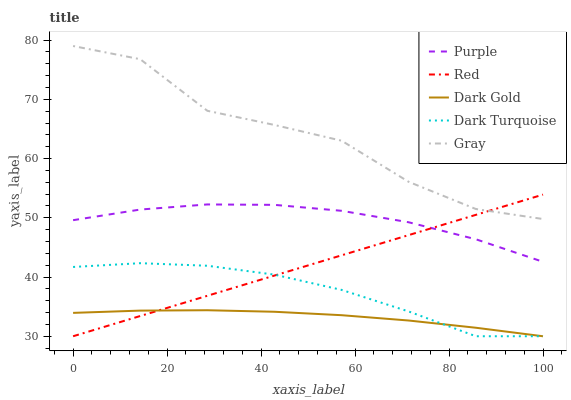Does Dark Turquoise have the minimum area under the curve?
Answer yes or no. No. Does Dark Turquoise have the maximum area under the curve?
Answer yes or no. No. Is Dark Turquoise the smoothest?
Answer yes or no. No. Is Dark Turquoise the roughest?
Answer yes or no. No. Does Gray have the lowest value?
Answer yes or no. No. Does Dark Turquoise have the highest value?
Answer yes or no. No. Is Dark Turquoise less than Purple?
Answer yes or no. Yes. Is Gray greater than Dark Gold?
Answer yes or no. Yes. Does Dark Turquoise intersect Purple?
Answer yes or no. No. 